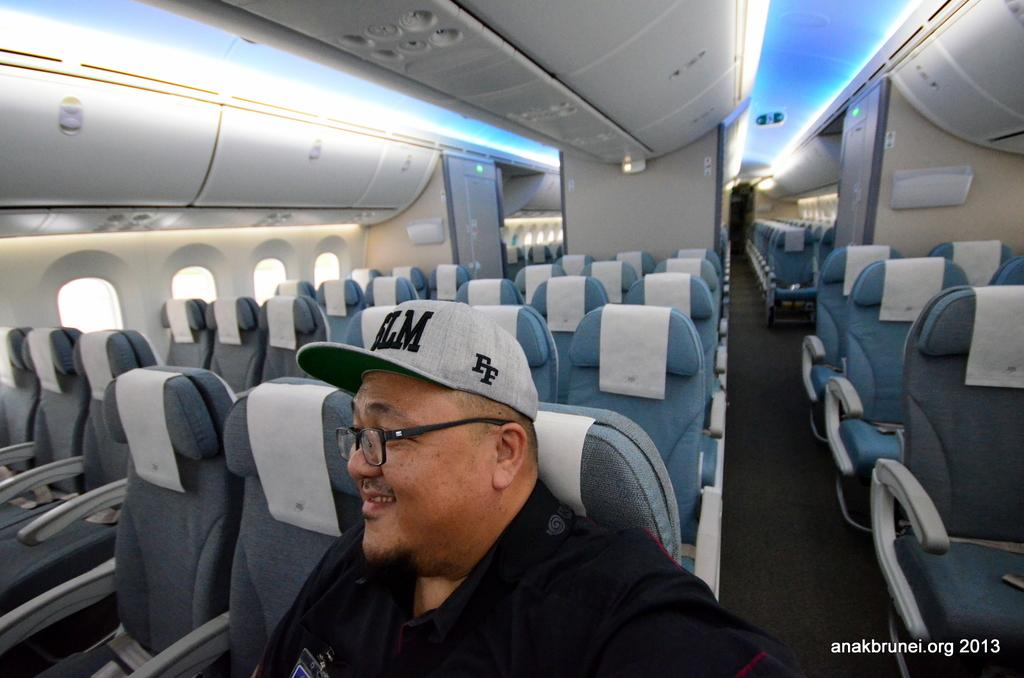Provide a one-sentence caption for the provided image. Man wearing a cap that says FF on an airplane. 